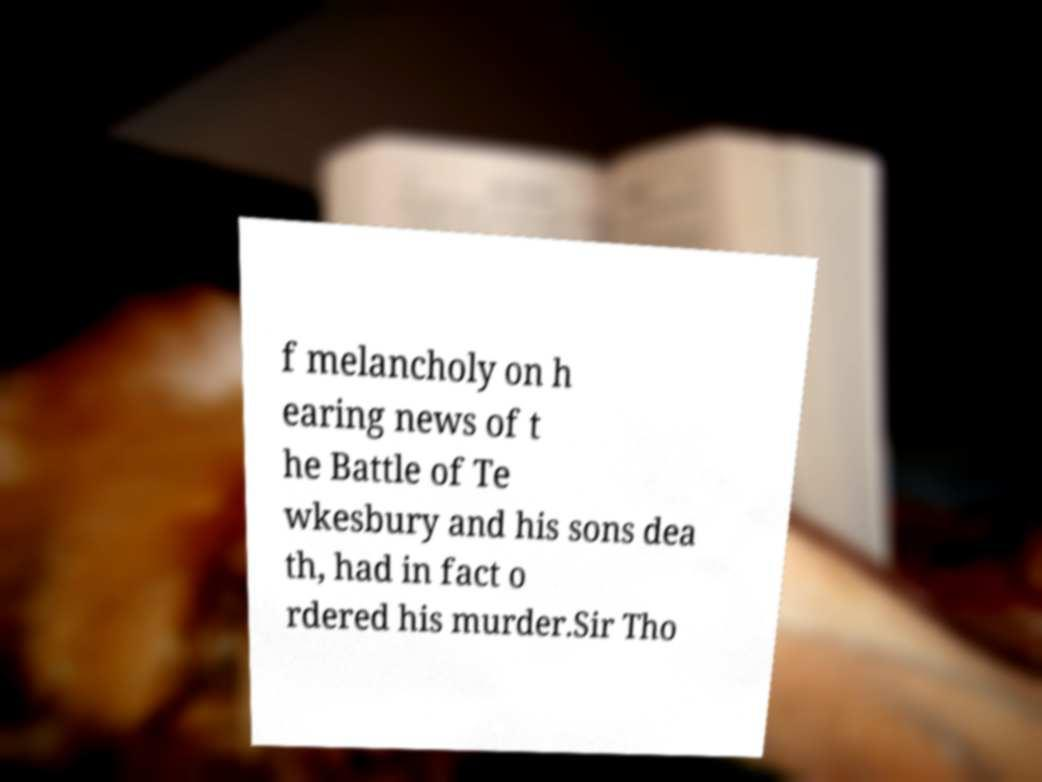There's text embedded in this image that I need extracted. Can you transcribe it verbatim? f melancholy on h earing news of t he Battle of Te wkesbury and his sons dea th, had in fact o rdered his murder.Sir Tho 